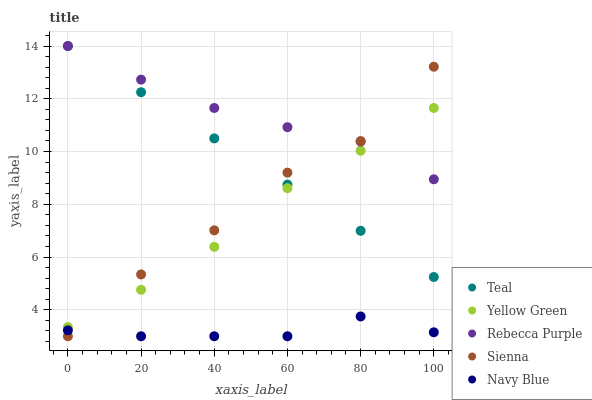Does Navy Blue have the minimum area under the curve?
Answer yes or no. Yes. Does Rebecca Purple have the maximum area under the curve?
Answer yes or no. Yes. Does Yellow Green have the minimum area under the curve?
Answer yes or no. No. Does Yellow Green have the maximum area under the curve?
Answer yes or no. No. Is Teal the smoothest?
Answer yes or no. Yes. Is Sienna the roughest?
Answer yes or no. Yes. Is Navy Blue the smoothest?
Answer yes or no. No. Is Navy Blue the roughest?
Answer yes or no. No. Does Sienna have the lowest value?
Answer yes or no. Yes. Does Yellow Green have the lowest value?
Answer yes or no. No. Does Rebecca Purple have the highest value?
Answer yes or no. Yes. Does Yellow Green have the highest value?
Answer yes or no. No. Is Navy Blue less than Yellow Green?
Answer yes or no. Yes. Is Teal greater than Navy Blue?
Answer yes or no. Yes. Does Teal intersect Sienna?
Answer yes or no. Yes. Is Teal less than Sienna?
Answer yes or no. No. Is Teal greater than Sienna?
Answer yes or no. No. Does Navy Blue intersect Yellow Green?
Answer yes or no. No. 